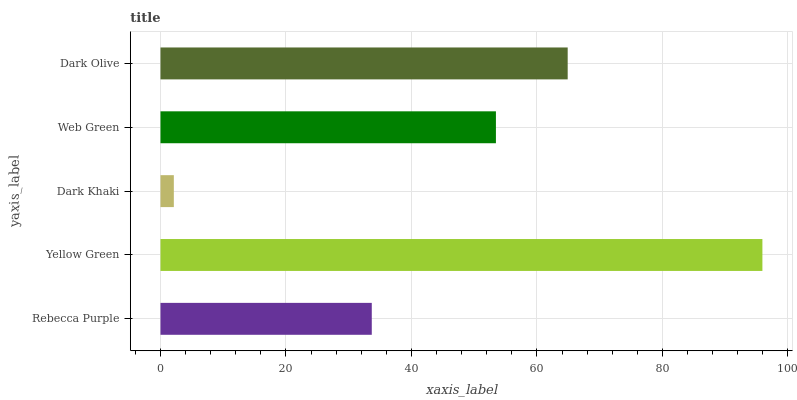Is Dark Khaki the minimum?
Answer yes or no. Yes. Is Yellow Green the maximum?
Answer yes or no. Yes. Is Yellow Green the minimum?
Answer yes or no. No. Is Dark Khaki the maximum?
Answer yes or no. No. Is Yellow Green greater than Dark Khaki?
Answer yes or no. Yes. Is Dark Khaki less than Yellow Green?
Answer yes or no. Yes. Is Dark Khaki greater than Yellow Green?
Answer yes or no. No. Is Yellow Green less than Dark Khaki?
Answer yes or no. No. Is Web Green the high median?
Answer yes or no. Yes. Is Web Green the low median?
Answer yes or no. Yes. Is Yellow Green the high median?
Answer yes or no. No. Is Rebecca Purple the low median?
Answer yes or no. No. 